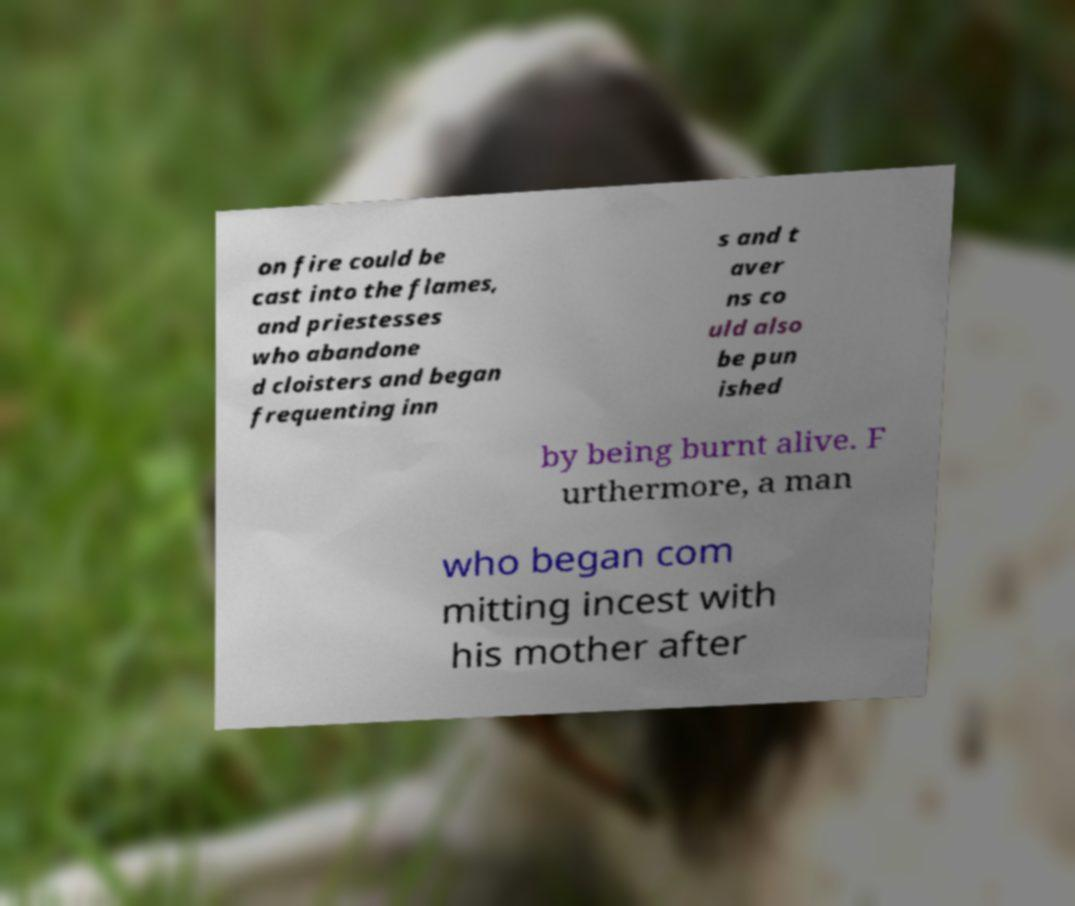Please identify and transcribe the text found in this image. on fire could be cast into the flames, and priestesses who abandone d cloisters and began frequenting inn s and t aver ns co uld also be pun ished by being burnt alive. F urthermore, a man who began com mitting incest with his mother after 